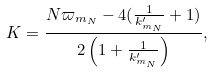<formula> <loc_0><loc_0><loc_500><loc_500>K = \frac { N \varpi _ { m _ { N } } - 4 ( \frac { 1 } { k ^ { \prime } _ { m _ { N } } } + 1 ) } { 2 \left ( 1 + \frac { 1 } { k ^ { \prime } _ { m _ { N } } } \right ) } ,</formula> 